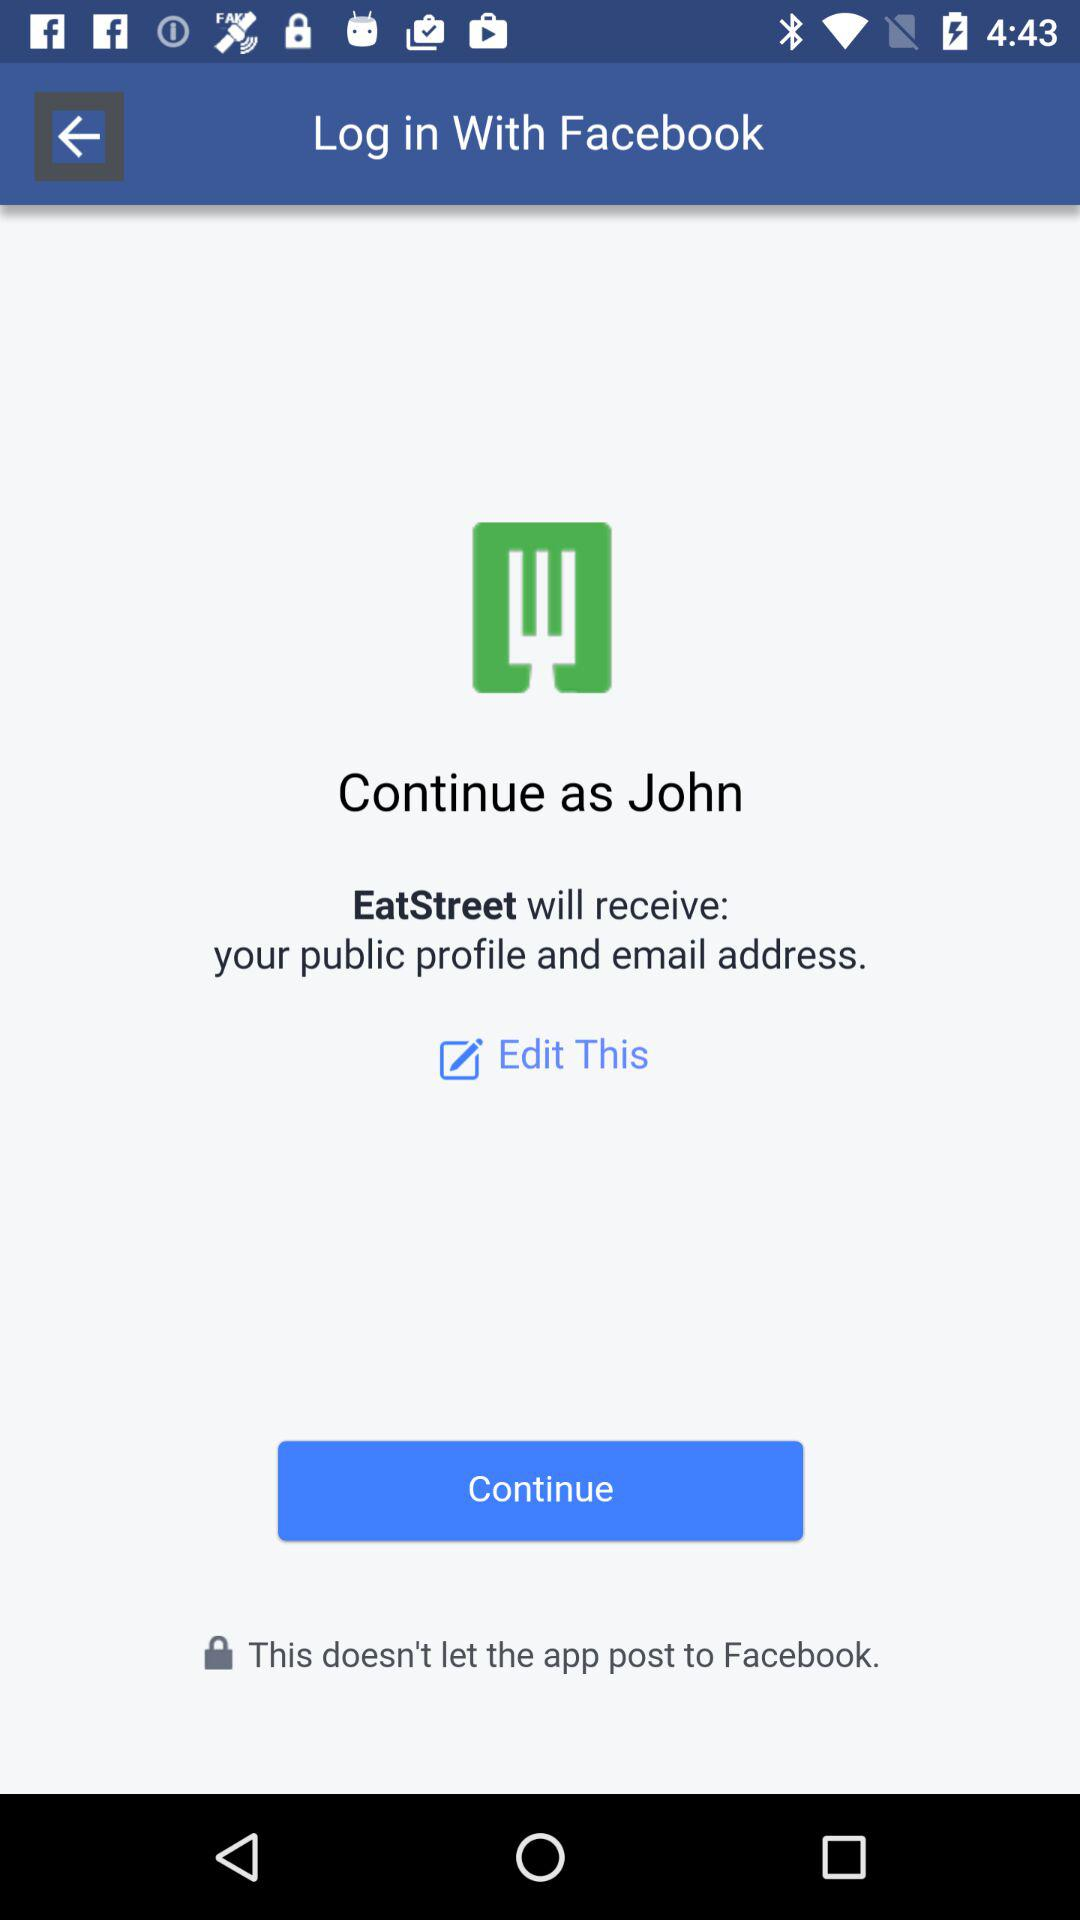Which application will receive my public profile and email address? Your public profile and email address will be received by "EatStreet". 